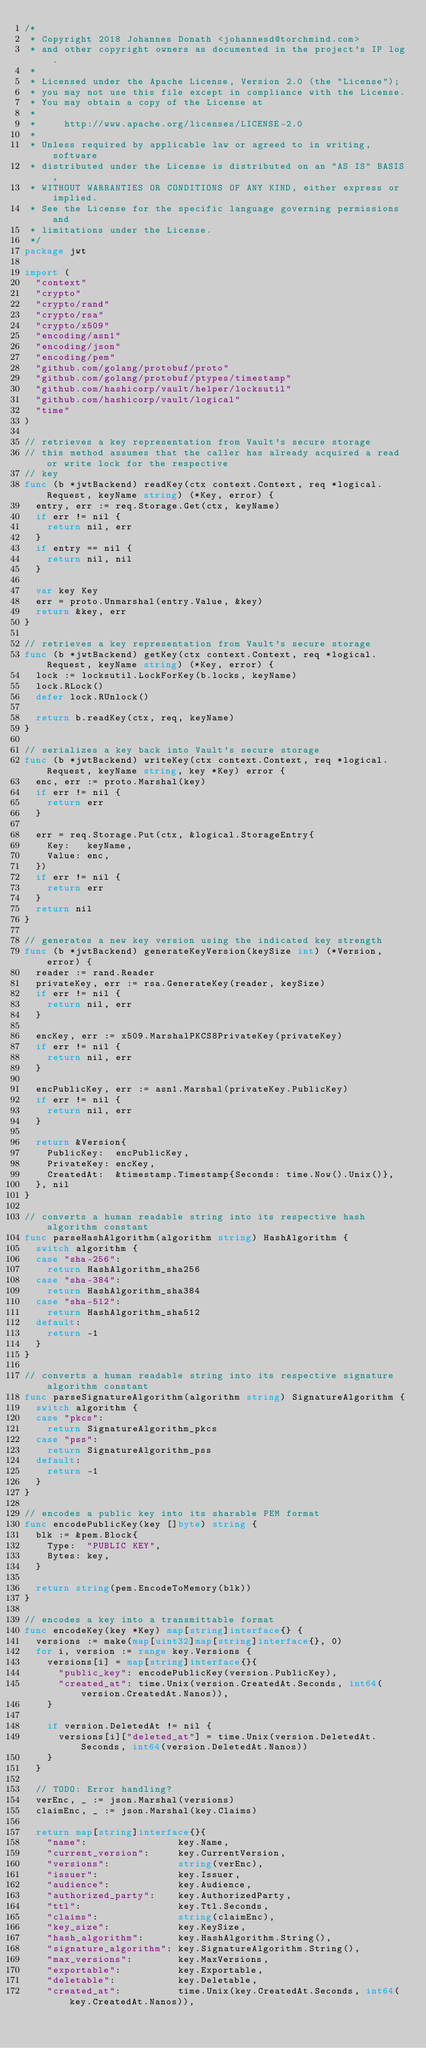<code> <loc_0><loc_0><loc_500><loc_500><_Go_>/*
 * Copyright 2018 Johannes Donath <johannesd@torchmind.com>
 * and other copyright owners as documented in the project's IP log.
 *
 * Licensed under the Apache License, Version 2.0 (the "License");
 * you may not use this file except in compliance with the License.
 * You may obtain a copy of the License at
 *
 *     http://www.apache.org/licenses/LICENSE-2.0
 *
 * Unless required by applicable law or agreed to in writing, software
 * distributed under the License is distributed on an "AS IS" BASIS,
 * WITHOUT WARRANTIES OR CONDITIONS OF ANY KIND, either express or implied.
 * See the License for the specific language governing permissions and
 * limitations under the License.
 */
package jwt

import (
  "context"
  "crypto"
  "crypto/rand"
  "crypto/rsa"
  "crypto/x509"
  "encoding/asn1"
  "encoding/json"
  "encoding/pem"
  "github.com/golang/protobuf/proto"
  "github.com/golang/protobuf/ptypes/timestamp"
  "github.com/hashicorp/vault/helper/locksutil"
  "github.com/hashicorp/vault/logical"
  "time"
)

// retrieves a key representation from Vault's secure storage
// this method assumes that the caller has already acquired a read or write lock for the respective
// key
func (b *jwtBackend) readKey(ctx context.Context, req *logical.Request, keyName string) (*Key, error) {
  entry, err := req.Storage.Get(ctx, keyName)
  if err != nil {
    return nil, err
  }
  if entry == nil {
    return nil, nil
  }

  var key Key
  err = proto.Unmarshal(entry.Value, &key)
  return &key, err
}

// retrieves a key representation from Vault's secure storage
func (b *jwtBackend) getKey(ctx context.Context, req *logical.Request, keyName string) (*Key, error) {
  lock := locksutil.LockForKey(b.locks, keyName)
  lock.RLock()
  defer lock.RUnlock()

  return b.readKey(ctx, req, keyName)
}

// serializes a key back into Vault's secure storage
func (b *jwtBackend) writeKey(ctx context.Context, req *logical.Request, keyName string, key *Key) error {
  enc, err := proto.Marshal(key)
  if err != nil {
    return err
  }

  err = req.Storage.Put(ctx, &logical.StorageEntry{
    Key:   keyName,
    Value: enc,
  })
  if err != nil {
    return err
  }
  return nil
}

// generates a new key version using the indicated key strength
func (b *jwtBackend) generateKeyVersion(keySize int) (*Version, error) {
  reader := rand.Reader
  privateKey, err := rsa.GenerateKey(reader, keySize)
  if err != nil {
    return nil, err
  }

  encKey, err := x509.MarshalPKCS8PrivateKey(privateKey)
  if err != nil {
    return nil, err
  }

  encPublicKey, err := asn1.Marshal(privateKey.PublicKey)
  if err != nil {
    return nil, err
  }

  return &Version{
    PublicKey:  encPublicKey,
    PrivateKey: encKey,
    CreatedAt:  &timestamp.Timestamp{Seconds: time.Now().Unix()},
  }, nil
}

// converts a human readable string into its respective hash algorithm constant
func parseHashAlgorithm(algorithm string) HashAlgorithm {
  switch algorithm {
  case "sha-256":
    return HashAlgorithm_sha256
  case "sha-384":
    return HashAlgorithm_sha384
  case "sha-512":
    return HashAlgorithm_sha512
  default:
    return -1
  }
}

// converts a human readable string into its respective signature algorithm constant
func parseSignatureAlgorithm(algorithm string) SignatureAlgorithm {
  switch algorithm {
  case "pkcs":
    return SignatureAlgorithm_pkcs
  case "pss":
    return SignatureAlgorithm_pss
  default:
    return -1
  }
}

// encodes a public key into its sharable PEM format
func encodePublicKey(key []byte) string {
  blk := &pem.Block{
    Type:  "PUBLIC KEY",
    Bytes: key,
  }

  return string(pem.EncodeToMemory(blk))
}

// encodes a key into a transmittable format
func encodeKey(key *Key) map[string]interface{} {
  versions := make(map[uint32]map[string]interface{}, 0)
  for i, version := range key.Versions {
    versions[i] = map[string]interface{}{
      "public_key": encodePublicKey(version.PublicKey),
      "created_at": time.Unix(version.CreatedAt.Seconds, int64(version.CreatedAt.Nanos)),
    }

    if version.DeletedAt != nil {
      versions[i]["deleted_at"] = time.Unix(version.DeletedAt.Seconds, int64(version.DeletedAt.Nanos))
    }
  }

  // TODO: Error handling?
  verEnc, _ := json.Marshal(versions)
  claimEnc, _ := json.Marshal(key.Claims)

  return map[string]interface{}{
    "name":                key.Name,
    "current_version":     key.CurrentVersion,
    "versions":            string(verEnc),
    "issuer":              key.Issuer,
    "audience":            key.Audience,
    "authorized_party":    key.AuthorizedParty,
    "ttl":                 key.Ttl.Seconds,
    "claims":              string(claimEnc),
    "key_size":            key.KeySize,
    "hash_algorithm":      key.HashAlgorithm.String(),
    "signature_algorithm": key.SignatureAlgorithm.String(),
    "max_versions":        key.MaxVersions,
    "exportable":          key.Exportable,
    "deletable":           key.Deletable,
    "created_at":          time.Unix(key.CreatedAt.Seconds, int64(key.CreatedAt.Nanos)),</code> 